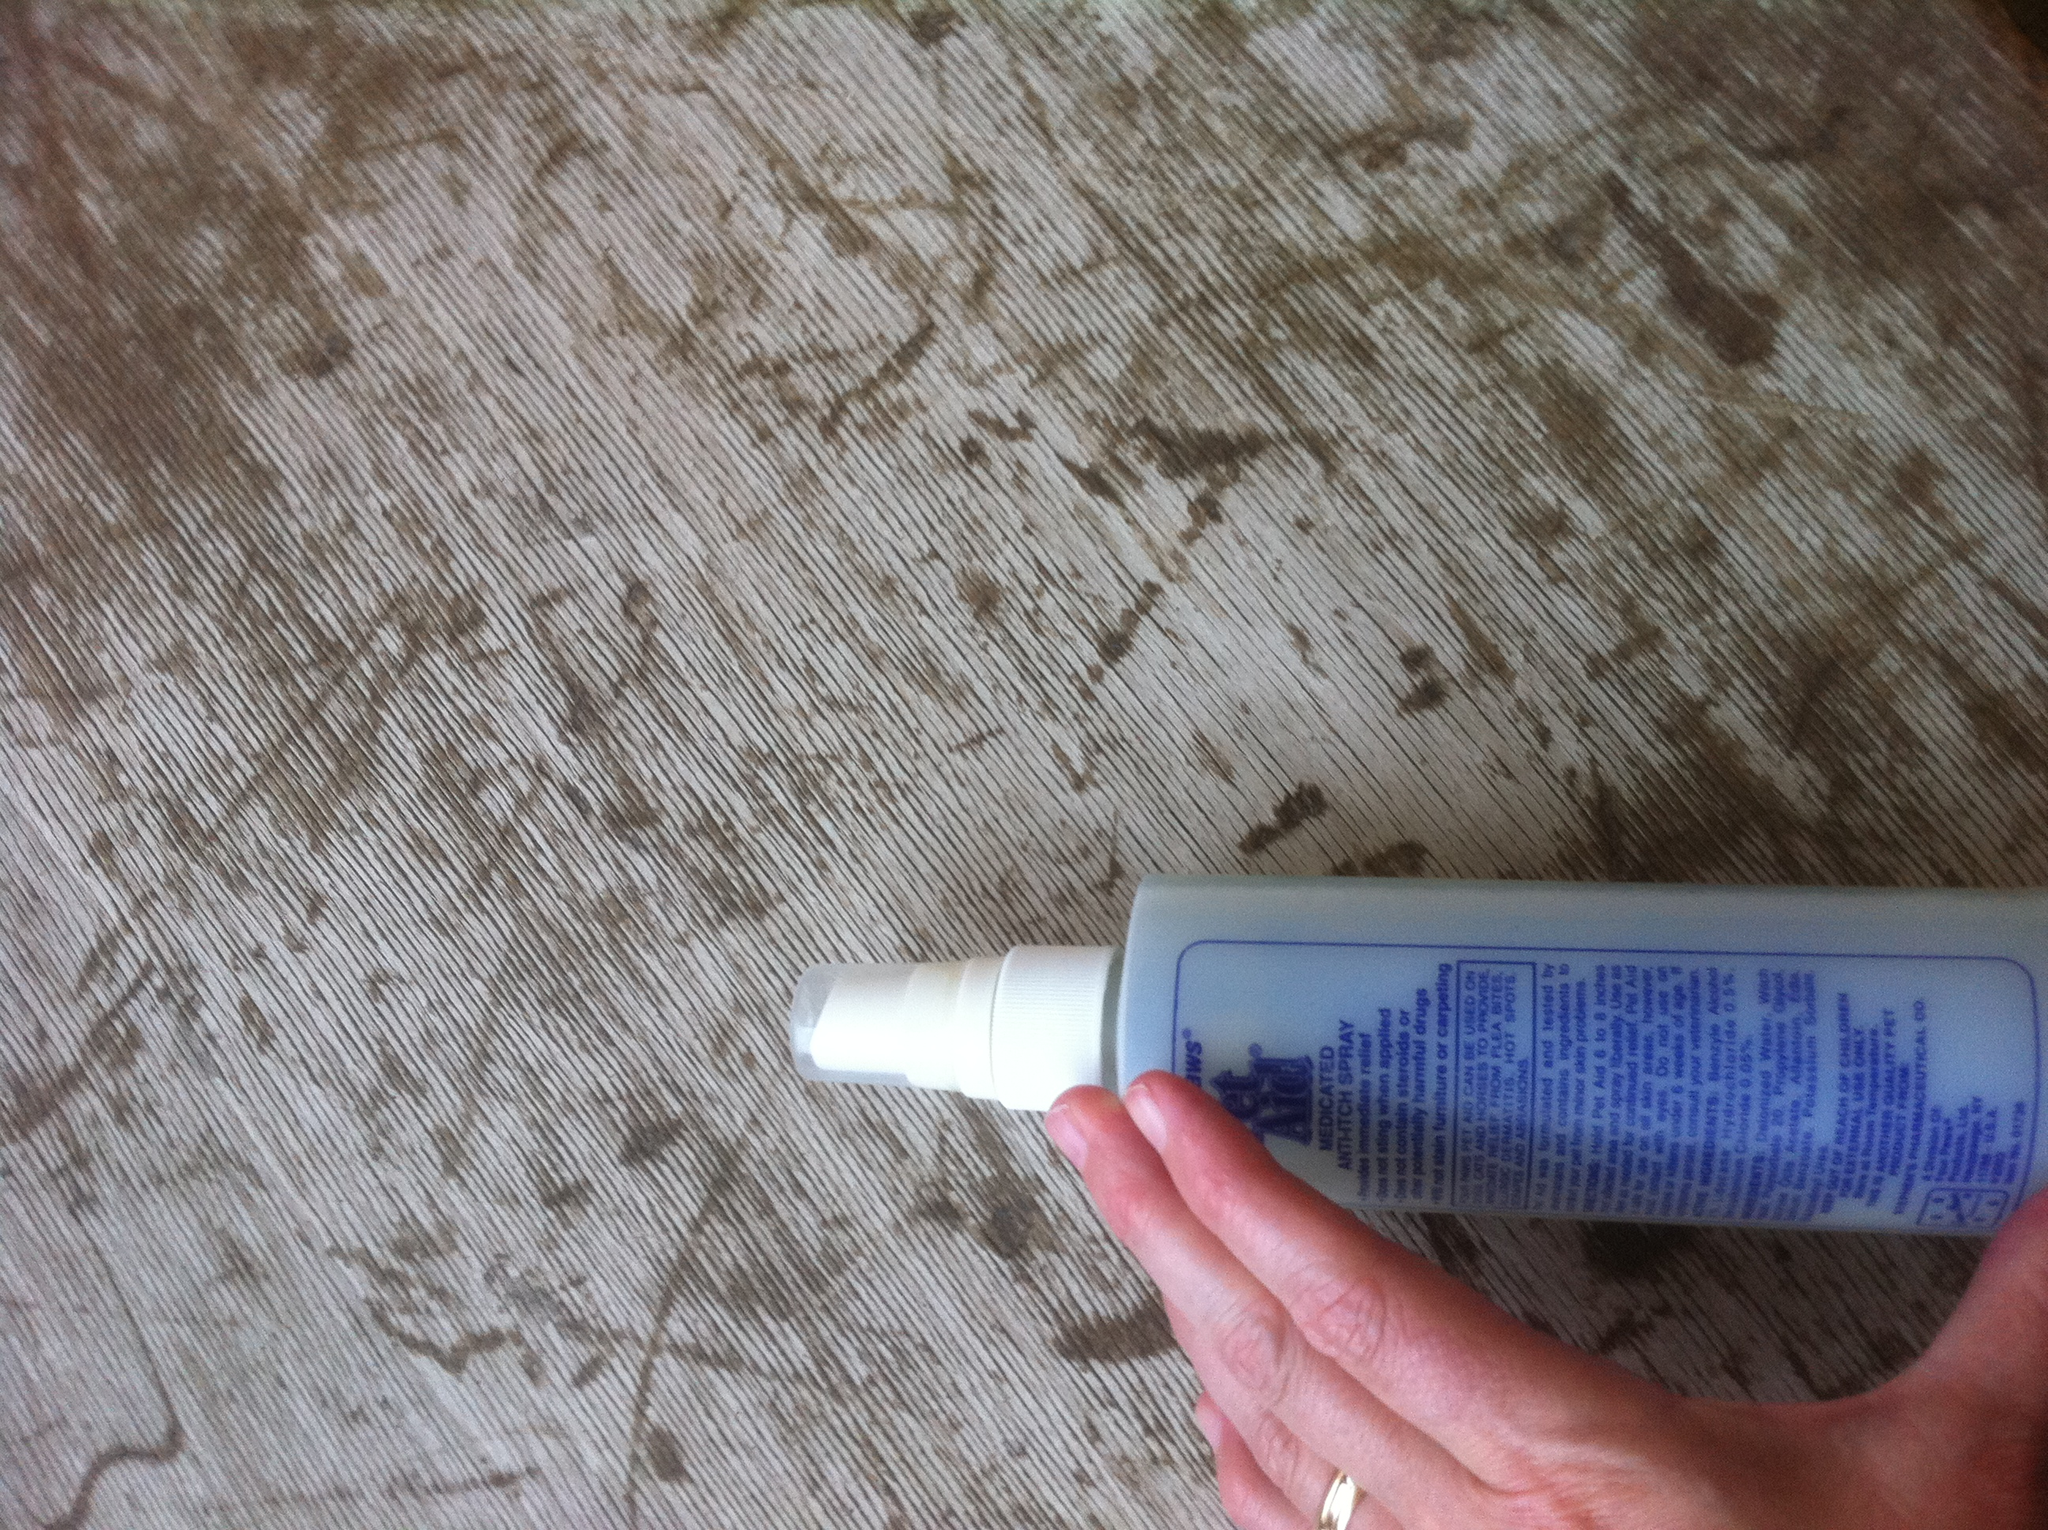Which dog product is this? The image shows a bottle of pet care spray, commonly used for dogs. This type of product is typically used to provide relief from itching, soothe skin irritations, or as a grooming aid. The specific brand and product details are listed on the label. 